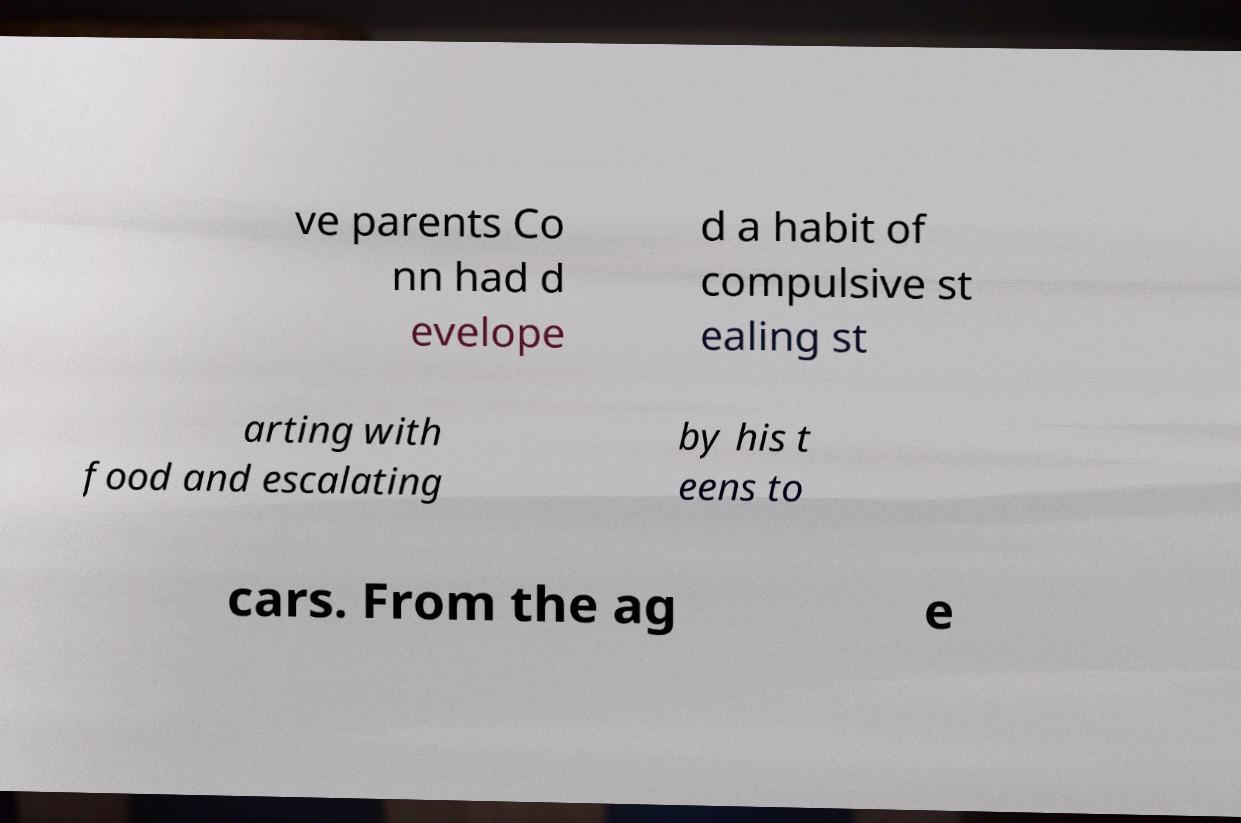Can you read and provide the text displayed in the image?This photo seems to have some interesting text. Can you extract and type it out for me? ve parents Co nn had d evelope d a habit of compulsive st ealing st arting with food and escalating by his t eens to cars. From the ag e 